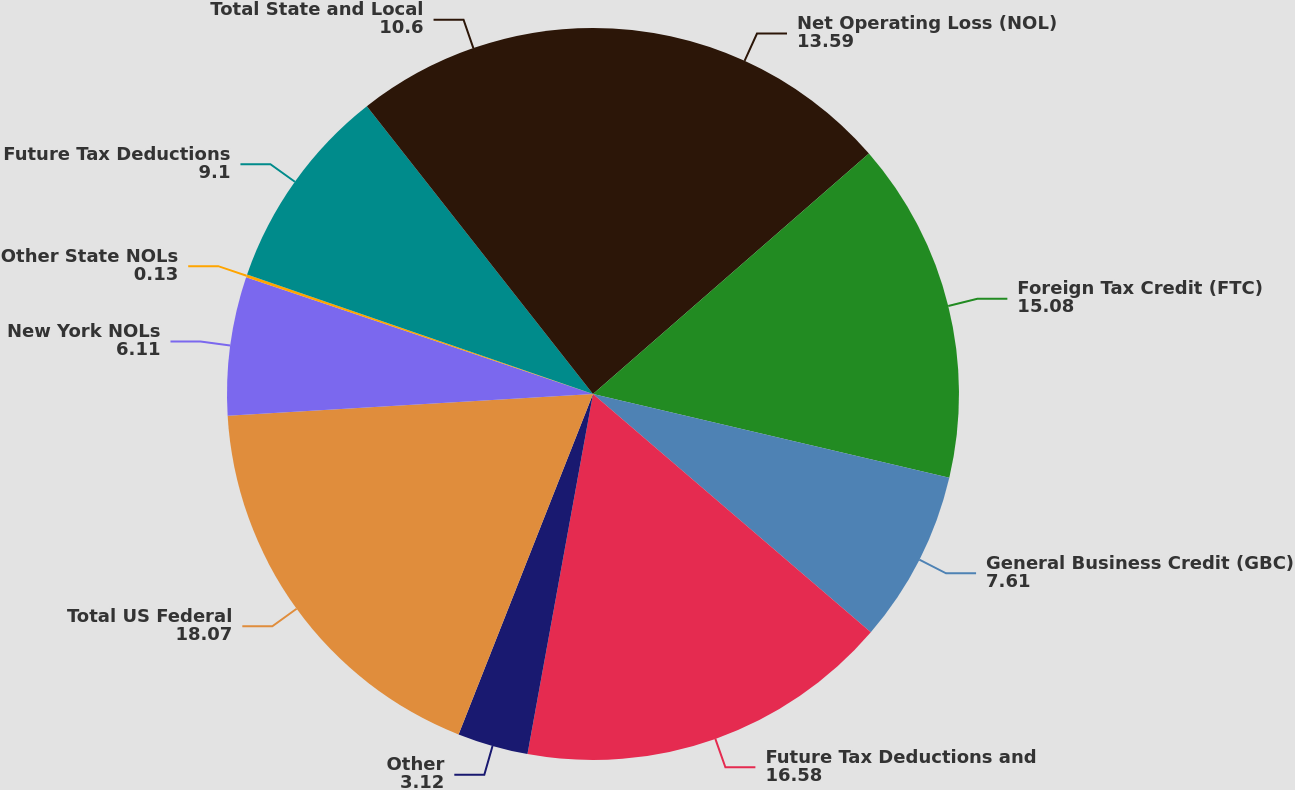Convert chart to OTSL. <chart><loc_0><loc_0><loc_500><loc_500><pie_chart><fcel>Net Operating Loss (NOL)<fcel>Foreign Tax Credit (FTC)<fcel>General Business Credit (GBC)<fcel>Future Tax Deductions and<fcel>Other<fcel>Total US Federal<fcel>New York NOLs<fcel>Other State NOLs<fcel>Future Tax Deductions<fcel>Total State and Local<nl><fcel>13.59%<fcel>15.08%<fcel>7.61%<fcel>16.58%<fcel>3.12%<fcel>18.07%<fcel>6.11%<fcel>0.13%<fcel>9.1%<fcel>10.6%<nl></chart> 